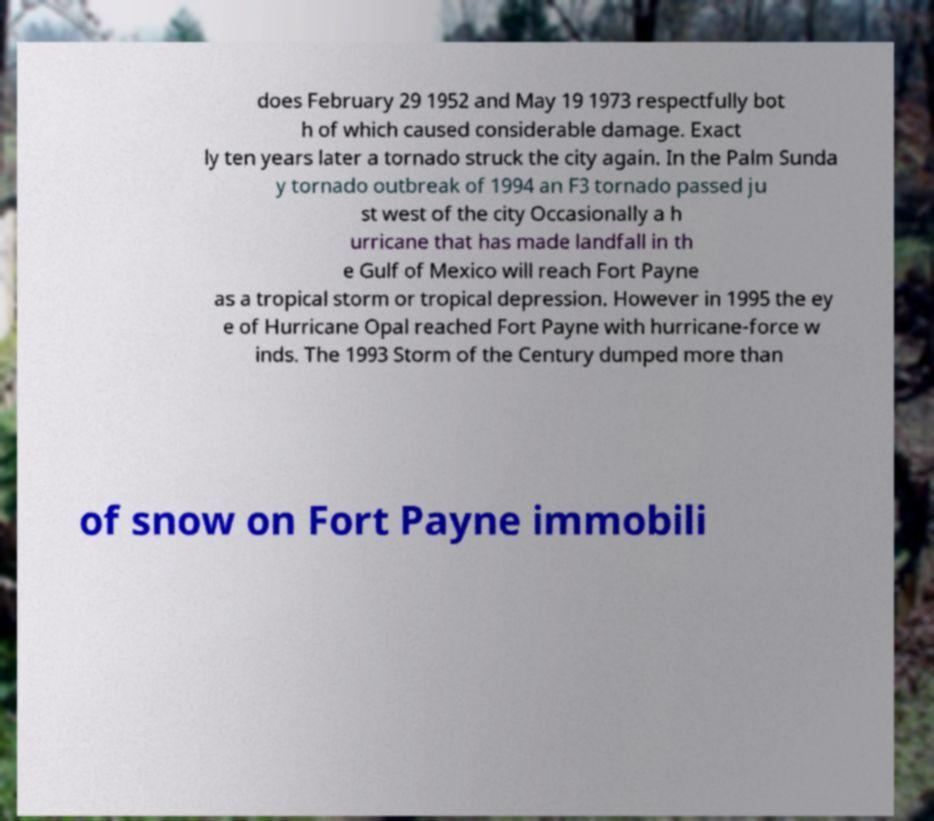Can you read and provide the text displayed in the image?This photo seems to have some interesting text. Can you extract and type it out for me? does February 29 1952 and May 19 1973 respectfully bot h of which caused considerable damage. Exact ly ten years later a tornado struck the city again. In the Palm Sunda y tornado outbreak of 1994 an F3 tornado passed ju st west of the city Occasionally a h urricane that has made landfall in th e Gulf of Mexico will reach Fort Payne as a tropical storm or tropical depression. However in 1995 the ey e of Hurricane Opal reached Fort Payne with hurricane-force w inds. The 1993 Storm of the Century dumped more than of snow on Fort Payne immobili 